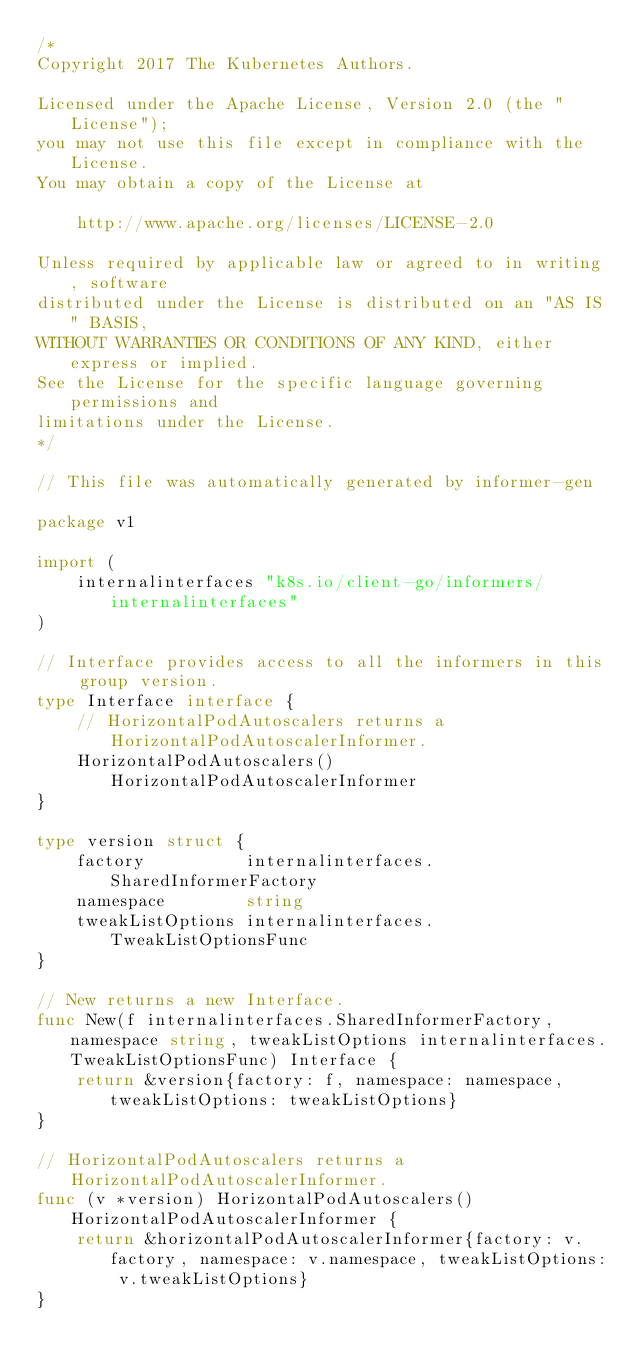Convert code to text. <code><loc_0><loc_0><loc_500><loc_500><_Go_>/*
Copyright 2017 The Kubernetes Authors.

Licensed under the Apache License, Version 2.0 (the "License");
you may not use this file except in compliance with the License.
You may obtain a copy of the License at

    http://www.apache.org/licenses/LICENSE-2.0

Unless required by applicable law or agreed to in writing, software
distributed under the License is distributed on an "AS IS" BASIS,
WITHOUT WARRANTIES OR CONDITIONS OF ANY KIND, either express or implied.
See the License for the specific language governing permissions and
limitations under the License.
*/

// This file was automatically generated by informer-gen

package v1

import (
	internalinterfaces "k8s.io/client-go/informers/internalinterfaces"
)

// Interface provides access to all the informers in this group version.
type Interface interface {
	// HorizontalPodAutoscalers returns a HorizontalPodAutoscalerInformer.
	HorizontalPodAutoscalers() HorizontalPodAutoscalerInformer
}

type version struct {
	factory          internalinterfaces.SharedInformerFactory
	namespace        string
	tweakListOptions internalinterfaces.TweakListOptionsFunc
}

// New returns a new Interface.
func New(f internalinterfaces.SharedInformerFactory, namespace string, tweakListOptions internalinterfaces.TweakListOptionsFunc) Interface {
	return &version{factory: f, namespace: namespace, tweakListOptions: tweakListOptions}
}

// HorizontalPodAutoscalers returns a HorizontalPodAutoscalerInformer.
func (v *version) HorizontalPodAutoscalers() HorizontalPodAutoscalerInformer {
	return &horizontalPodAutoscalerInformer{factory: v.factory, namespace: v.namespace, tweakListOptions: v.tweakListOptions}
}
</code> 